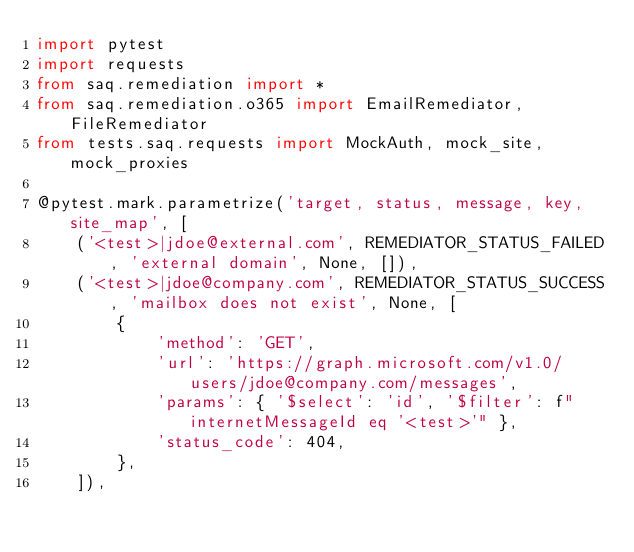<code> <loc_0><loc_0><loc_500><loc_500><_Python_>import pytest
import requests
from saq.remediation import *
from saq.remediation.o365 import EmailRemediator, FileRemediator
from tests.saq.requests import MockAuth, mock_site, mock_proxies

@pytest.mark.parametrize('target, status, message, key, site_map', [
    ('<test>|jdoe@external.com', REMEDIATOR_STATUS_FAILED, 'external domain', None, []),
    ('<test>|jdoe@company.com', REMEDIATOR_STATUS_SUCCESS, 'mailbox does not exist', None, [
        {
            'method': 'GET',
            'url': 'https://graph.microsoft.com/v1.0/users/jdoe@company.com/messages',
            'params': { '$select': 'id', '$filter': f"internetMessageId eq '<test>'" },
            'status_code': 404,
        },
    ]),</code> 